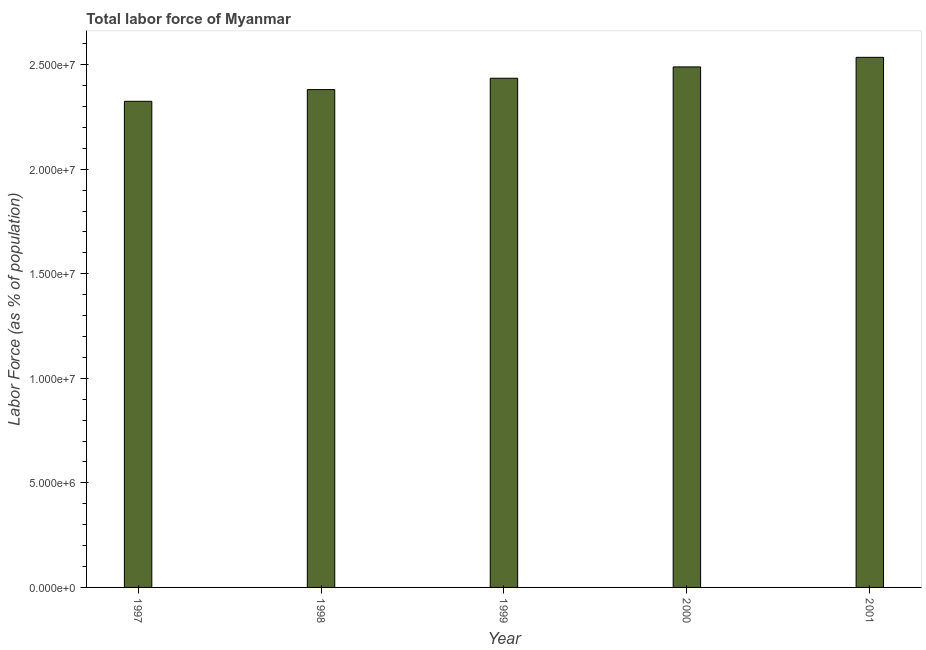Does the graph contain any zero values?
Provide a succinct answer. No. What is the title of the graph?
Provide a short and direct response. Total labor force of Myanmar. What is the label or title of the Y-axis?
Your response must be concise. Labor Force (as % of population). What is the total labor force in 1999?
Give a very brief answer. 2.44e+07. Across all years, what is the maximum total labor force?
Offer a very short reply. 2.54e+07. Across all years, what is the minimum total labor force?
Give a very brief answer. 2.32e+07. In which year was the total labor force maximum?
Offer a terse response. 2001. What is the sum of the total labor force?
Offer a very short reply. 1.22e+08. What is the difference between the total labor force in 1997 and 2001?
Give a very brief answer. -2.10e+06. What is the average total labor force per year?
Ensure brevity in your answer.  2.43e+07. What is the median total labor force?
Your answer should be compact. 2.44e+07. In how many years, is the total labor force greater than 16000000 %?
Give a very brief answer. 5. What is the ratio of the total labor force in 2000 to that in 2001?
Provide a succinct answer. 0.98. Is the total labor force in 1997 less than that in 1998?
Offer a terse response. Yes. Is the difference between the total labor force in 1997 and 1999 greater than the difference between any two years?
Your response must be concise. No. What is the difference between the highest and the second highest total labor force?
Provide a short and direct response. 4.58e+05. What is the difference between the highest and the lowest total labor force?
Offer a very short reply. 2.10e+06. What is the difference between two consecutive major ticks on the Y-axis?
Offer a very short reply. 5.00e+06. What is the Labor Force (as % of population) of 1997?
Offer a very short reply. 2.32e+07. What is the Labor Force (as % of population) in 1998?
Offer a terse response. 2.38e+07. What is the Labor Force (as % of population) in 1999?
Ensure brevity in your answer.  2.44e+07. What is the Labor Force (as % of population) in 2000?
Make the answer very short. 2.49e+07. What is the Labor Force (as % of population) of 2001?
Your answer should be very brief. 2.54e+07. What is the difference between the Labor Force (as % of population) in 1997 and 1998?
Your response must be concise. -5.60e+05. What is the difference between the Labor Force (as % of population) in 1997 and 1999?
Your response must be concise. -1.10e+06. What is the difference between the Labor Force (as % of population) in 1997 and 2000?
Give a very brief answer. -1.64e+06. What is the difference between the Labor Force (as % of population) in 1997 and 2001?
Make the answer very short. -2.10e+06. What is the difference between the Labor Force (as % of population) in 1998 and 1999?
Offer a very short reply. -5.44e+05. What is the difference between the Labor Force (as % of population) in 1998 and 2000?
Ensure brevity in your answer.  -1.09e+06. What is the difference between the Labor Force (as % of population) in 1998 and 2001?
Make the answer very short. -1.54e+06. What is the difference between the Labor Force (as % of population) in 1999 and 2000?
Ensure brevity in your answer.  -5.42e+05. What is the difference between the Labor Force (as % of population) in 1999 and 2001?
Your response must be concise. -1.00e+06. What is the difference between the Labor Force (as % of population) in 2000 and 2001?
Offer a very short reply. -4.58e+05. What is the ratio of the Labor Force (as % of population) in 1997 to that in 1999?
Provide a short and direct response. 0.95. What is the ratio of the Labor Force (as % of population) in 1997 to that in 2000?
Make the answer very short. 0.93. What is the ratio of the Labor Force (as % of population) in 1997 to that in 2001?
Ensure brevity in your answer.  0.92. What is the ratio of the Labor Force (as % of population) in 1998 to that in 2000?
Offer a very short reply. 0.96. What is the ratio of the Labor Force (as % of population) in 1998 to that in 2001?
Your answer should be very brief. 0.94. What is the ratio of the Labor Force (as % of population) in 1999 to that in 2000?
Make the answer very short. 0.98. What is the ratio of the Labor Force (as % of population) in 1999 to that in 2001?
Keep it short and to the point. 0.96. 